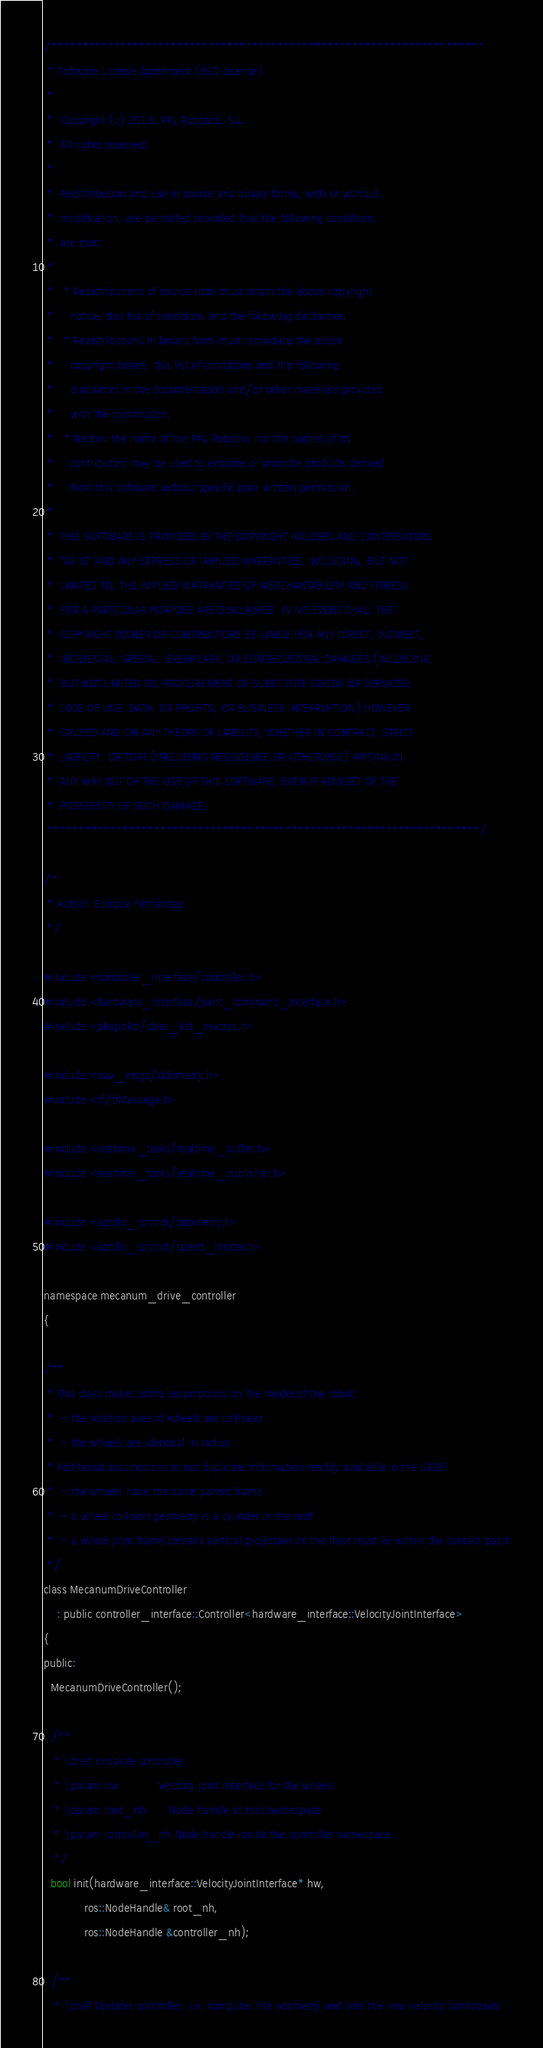<code> <loc_0><loc_0><loc_500><loc_500><_C_>/*********************************************************************
 * Software License Agreement (BSD License)
 *
 *  Copyright (c) 2013, PAL Robotics, S.L.
 *  All rights reserved.
 *
 *  Redistribution and use in source and binary forms, with or without
 *  modification, are permitted provided that the following conditions
 *  are met:
 *
 *   * Redistributions of source code must retain the above copyright
 *     notice, this list of conditions and the following disclaimer.
 *   * Redistributions in binary form must reproduce the above
 *     copyright notice, this list of conditions and the following
 *     disclaimer in the documentation and/or other materials provided
 *     with the distribution.
 *   * Neither the name of the PAL Robotics nor the names of its
 *     contributors may be used to endorse or promote products derived
 *     from this software without specific prior written permission.
 *
 *  THIS SOFTWARE IS PROVIDED BY THE COPYRIGHT HOLDERS AND CONTRIBUTORS
 *  "AS IS" AND ANY EXPRESS OR IMPLIED WARRANTIES, INCLUDING, BUT NOT
 *  LIMITED TO, THE IMPLIED WARRANTIES OF MERCHANTABILITY AND FITNESS
 *  FOR A PARTICULAR PURPOSE ARE DISCLAIMED. IN NO EVENT SHALL THE
 *  COPYRIGHT OWNER OR CONTRIBUTORS BE LIABLE FOR ANY DIRECT, INDIRECT,
 *  INCIDENTAL, SPECIAL, EXEMPLARY, OR CONSEQUENTIAL DAMAGES (INCLUDING,
 *  BUT NOT LIMITED TO, PROCUREMENT OF SUBSTITUTE GOODS OR SERVICES;
 *  LOSS OF USE, DATA, OR PROFITS; OR BUSINESS INTERRUPTION) HOWEVER
 *  CAUSED AND ON ANY THEORY OF LIABILITY, WHETHER IN CONTRACT, STRICT
 *  LIABILITY, OR TORT (INCLUDING NEGLIGENCE OR OTHERWISE) ARISING IN
 *  ANY WAY OUT OF THE USE OF THIS SOFTWARE, EVEN IF ADVISED OF THE
 *  POSSIBILITY OF SUCH DAMAGE.
 *********************************************************************/

/*
 * Author: Enrique Fernández
 */

#include <controller_interface/controller.h>
#include <hardware_interface/joint_command_interface.h>
#include <pluginlib/class_list_macros.h>

#include <nav_msgs/Odometry.h>
#include <tf/tfMessage.h>

#include <realtime_tools/realtime_buffer.h>
#include <realtime_tools/realtime_publisher.h>

#include <apollo_control/odometry.h>
#include <apollo_control/speed_limiter.h>

namespace mecanum_drive_controller
{

/**
 * This class makes some assumptions on the model of the robot:
 *  - the rotation axes of wheels are collinear
 *  - the wheels are identical in radius
 * Additional assumptions to not duplicate information readily available in the URDF:
 *  - the wheels have the same parent frame
 *  - a wheel collision geometry is a cylinder in the urdf
 *  - a wheel joint frame center's vertical projection on the floor must lie within the contact patch
 */
class MecanumDriveController
    : public controller_interface::Controller<hardware_interface::VelocityJointInterface>
{
public:
  MecanumDriveController();

  /**
   * \brief Initialize controller
   * \param hw            Velocity joint interface for the wheels
   * \param root_nh       Node handle at root namespace
   * \param controller_nh Node handle inside the controller namespace
   */
  bool init(hardware_interface::VelocityJointInterface* hw,
            ros::NodeHandle& root_nh,
            ros::NodeHandle &controller_nh);

  /**
   * \brief Updates controller, i.e. computes the odometry and sets the new velocity commands</code> 